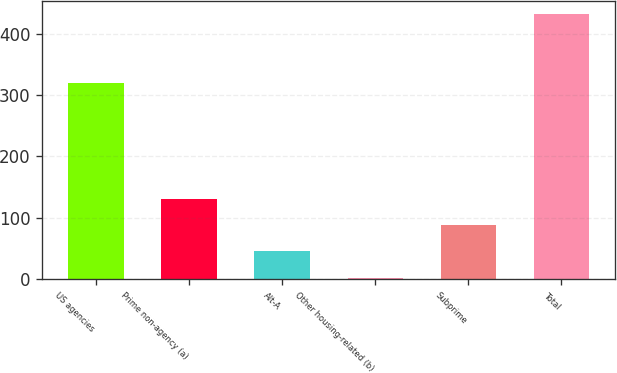Convert chart. <chart><loc_0><loc_0><loc_500><loc_500><bar_chart><fcel>US agencies<fcel>Prime non-agency (a)<fcel>Alt-A<fcel>Other housing-related (b)<fcel>Subprime<fcel>Total<nl><fcel>320<fcel>131.3<fcel>45.1<fcel>2<fcel>88.2<fcel>433<nl></chart> 